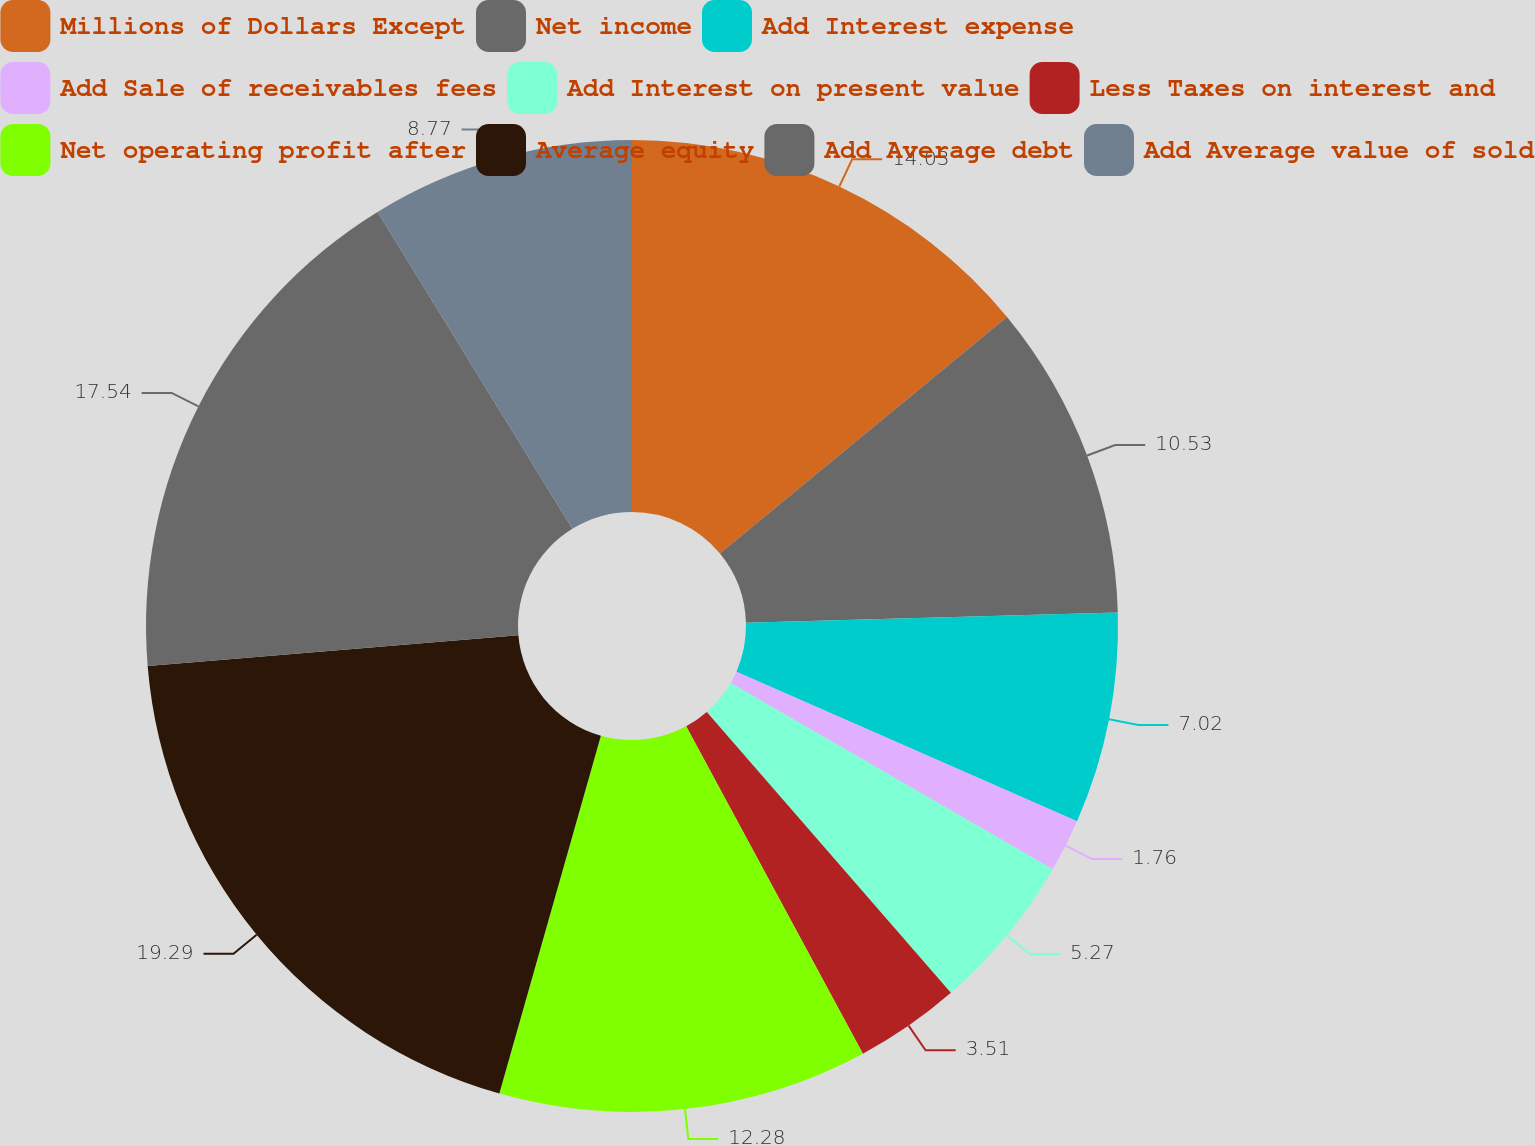Convert chart. <chart><loc_0><loc_0><loc_500><loc_500><pie_chart><fcel>Millions of Dollars Except<fcel>Net income<fcel>Add Interest expense<fcel>Add Sale of receivables fees<fcel>Add Interest on present value<fcel>Less Taxes on interest and<fcel>Net operating profit after<fcel>Average equity<fcel>Add Average debt<fcel>Add Average value of sold<nl><fcel>14.03%<fcel>10.53%<fcel>7.02%<fcel>1.76%<fcel>5.27%<fcel>3.51%<fcel>12.28%<fcel>19.29%<fcel>17.54%<fcel>8.77%<nl></chart> 